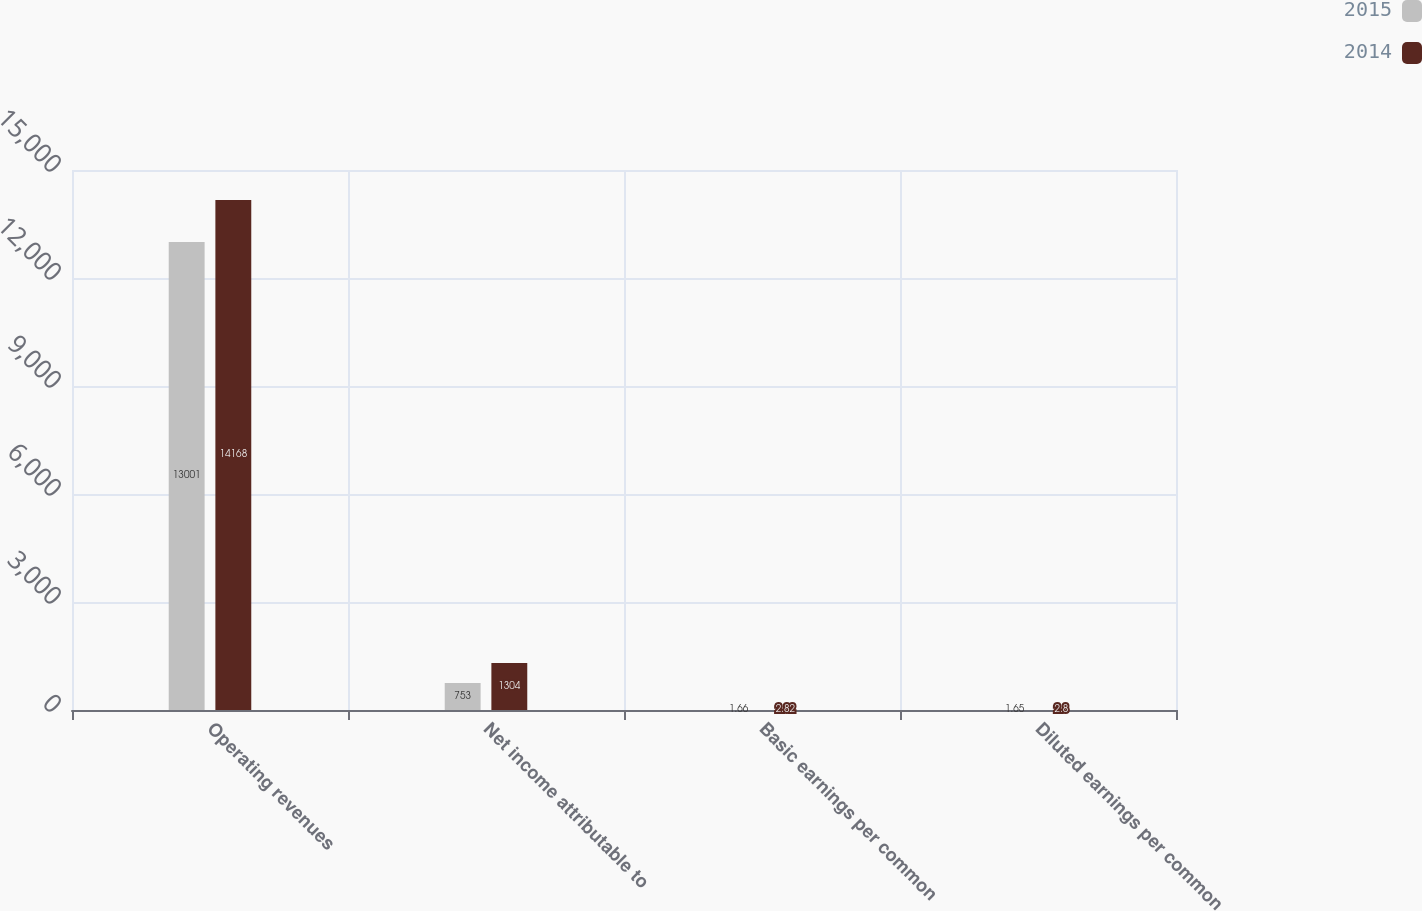Convert chart. <chart><loc_0><loc_0><loc_500><loc_500><stacked_bar_chart><ecel><fcel>Operating revenues<fcel>Net income attributable to<fcel>Basic earnings per common<fcel>Diluted earnings per common<nl><fcel>2015<fcel>13001<fcel>753<fcel>1.66<fcel>1.65<nl><fcel>2014<fcel>14168<fcel>1304<fcel>2.82<fcel>2.8<nl></chart> 